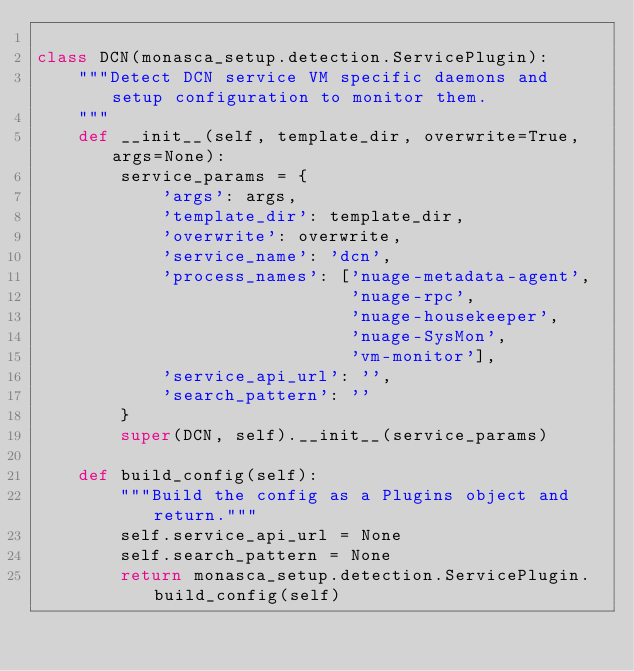Convert code to text. <code><loc_0><loc_0><loc_500><loc_500><_Python_>
class DCN(monasca_setup.detection.ServicePlugin):
    """Detect DCN service VM specific daemons and setup configuration to monitor them.
    """
    def __init__(self, template_dir, overwrite=True, args=None):
        service_params = {
            'args': args,
            'template_dir': template_dir,
            'overwrite': overwrite,
            'service_name': 'dcn',
            'process_names': ['nuage-metadata-agent',
                              'nuage-rpc',
                              'nuage-housekeeper',
                              'nuage-SysMon',
                              'vm-monitor'],
            'service_api_url': '',
            'search_pattern': ''
        }
        super(DCN, self).__init__(service_params)

    def build_config(self):
        """Build the config as a Plugins object and return."""
        self.service_api_url = None
        self.search_pattern = None
        return monasca_setup.detection.ServicePlugin.build_config(self)
</code> 